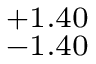Convert formula to latex. <formula><loc_0><loc_0><loc_500><loc_500>_ { - 1 . 4 0 } ^ { + 1 . 4 0 }</formula> 